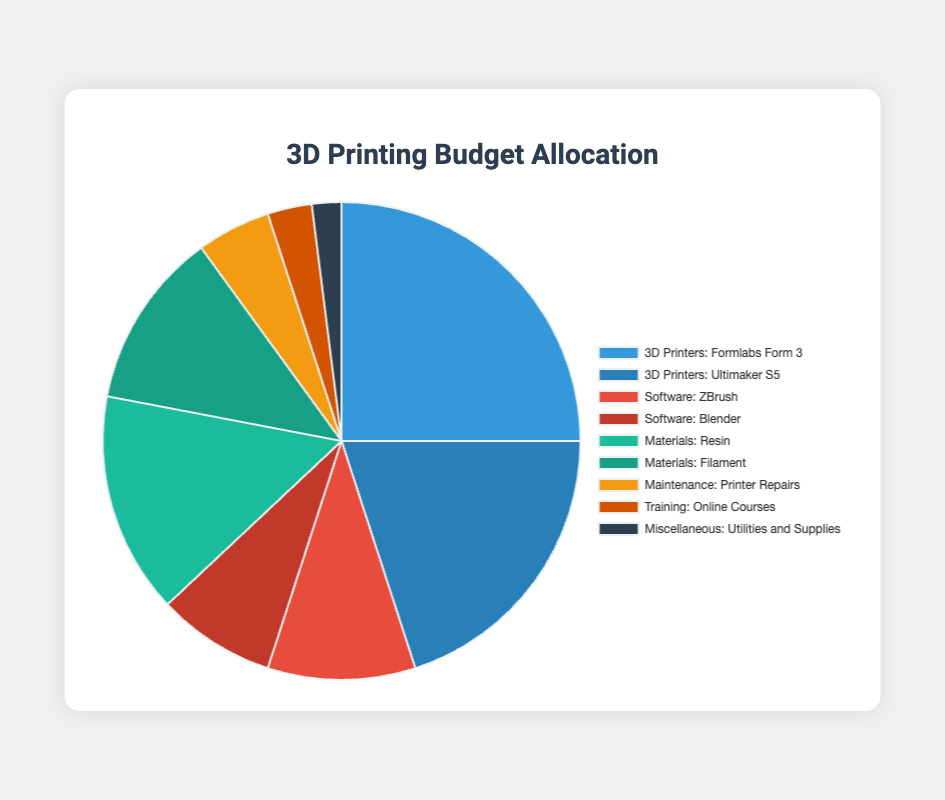What is the total budget allocated for 3D printers? The figure shows two categories under "3D Printers": "Formlabs Form 3" and "Ultimaker S5". Add their amounts: 25000 + 20000 = 45000.
Answer: 45000 Which category received the highest budget allocation? By observing the pie chart, the largest segment corresponds to the category "3D Printers" with "Formlabs Form 3" ($25,000).
Answer: 3D Printers How much more budget is allocated to "Resin" compared to "Filament"? The budget for "Resin" is $15,000 and for "Filament" is $12,000. The difference is 15000 - 12000 = 3000.
Answer: 3000 Which category has the smallest budget allocation? By looking at the pie chart, the smallest segment corresponds to "Miscellaneous: Utilities and Supplies" with $2,000.
Answer: Miscellaneous What is the average budget allocated for the categories under "Software"? The budget allocations for "Software" are $10,000 for "ZBrush" and $8,000 for "Blender". The total is 10000 + 8000 = 18000. The average is 18000 / 2 = 9000.
Answer: 9000 How much is allocated in total for "Materials"? The allocations for "Materials" are $15,000 for "Resin" and $12,000 for "Filament". The total is 15000 + 12000 = 27000.
Answer: 27000 What percentage of the total budget is allocated to "Online Courses"? The budget for "Training: Online Courses" is $3,000. To find the percentage: (3000 / 100000) * 100 = 3%.
Answer: 3% Which has a greater allocation, "Maintenance" or "Training"? By how much? The budget for "Maintenance: Printer Repairs" is $5,000, and for "Training: Online Courses" is $3,000. Maintenance has a greater allocation by 5000 - 3000 = 2000.
Answer: Maintenance, by 2000 